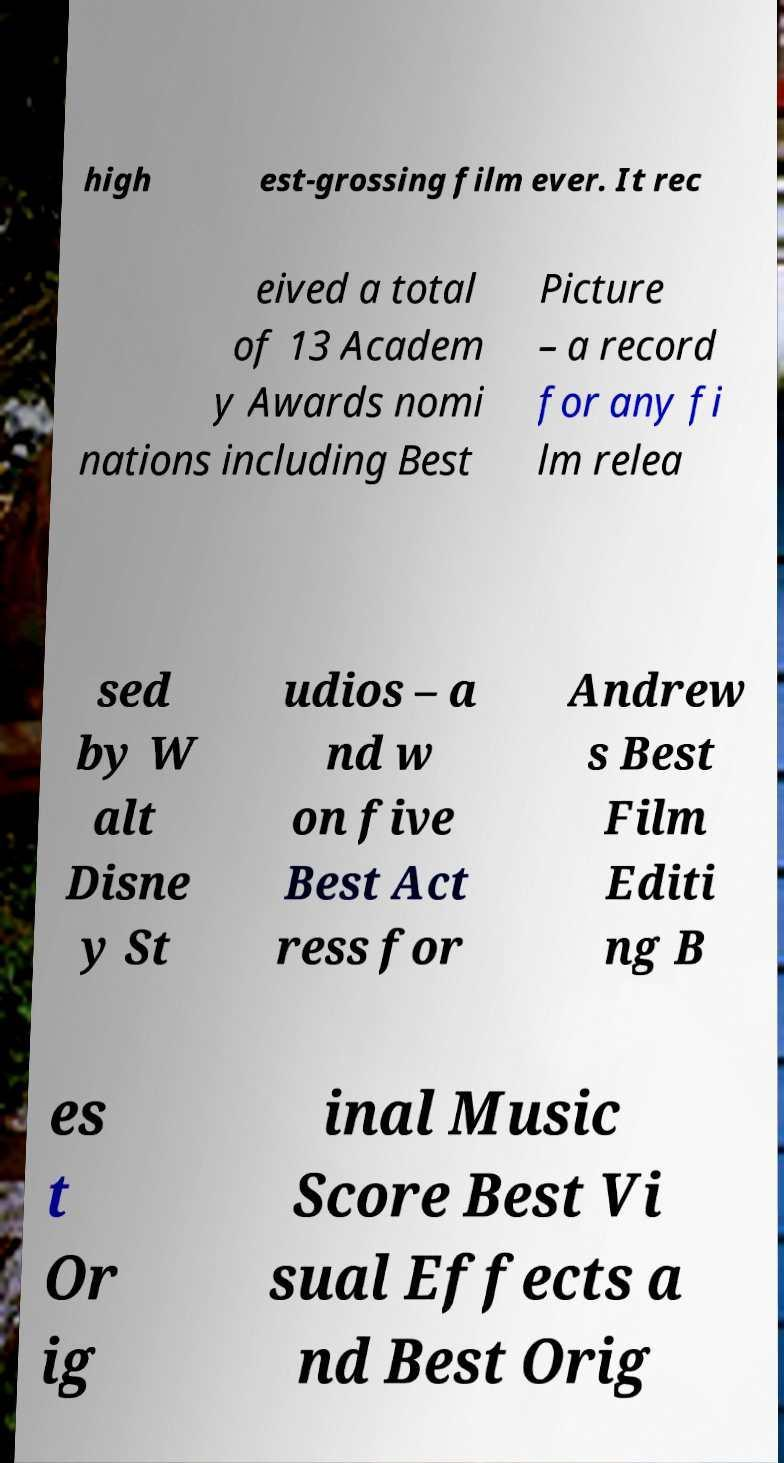Can you read and provide the text displayed in the image?This photo seems to have some interesting text. Can you extract and type it out for me? high est-grossing film ever. It rec eived a total of 13 Academ y Awards nomi nations including Best Picture – a record for any fi lm relea sed by W alt Disne y St udios – a nd w on five Best Act ress for Andrew s Best Film Editi ng B es t Or ig inal Music Score Best Vi sual Effects a nd Best Orig 